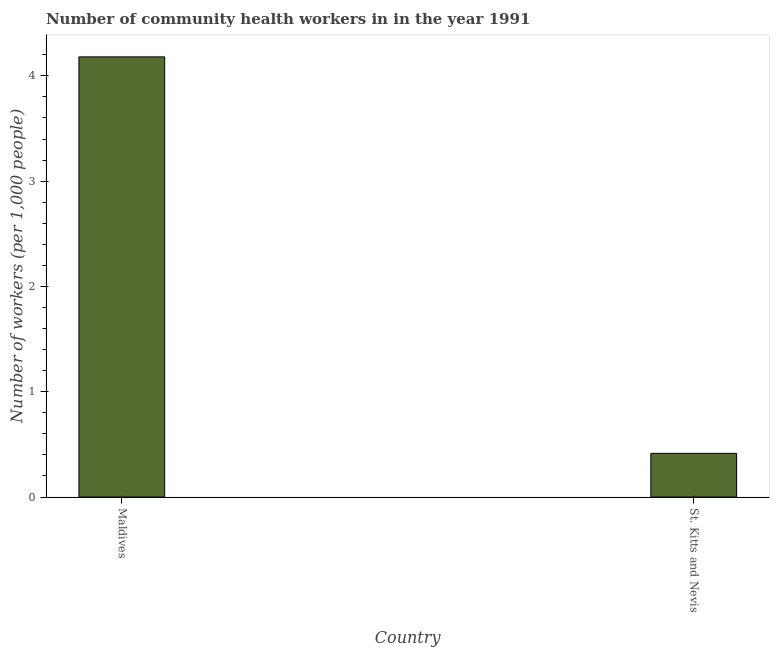Does the graph contain any zero values?
Provide a succinct answer. No. What is the title of the graph?
Keep it short and to the point. Number of community health workers in in the year 1991. What is the label or title of the Y-axis?
Provide a short and direct response. Number of workers (per 1,0 people). What is the number of community health workers in St. Kitts and Nevis?
Make the answer very short. 0.41. Across all countries, what is the maximum number of community health workers?
Your response must be concise. 4.18. Across all countries, what is the minimum number of community health workers?
Your answer should be very brief. 0.41. In which country was the number of community health workers maximum?
Give a very brief answer. Maldives. In which country was the number of community health workers minimum?
Offer a very short reply. St. Kitts and Nevis. What is the sum of the number of community health workers?
Your answer should be compact. 4.59. What is the difference between the number of community health workers in Maldives and St. Kitts and Nevis?
Provide a succinct answer. 3.77. What is the average number of community health workers per country?
Give a very brief answer. 2.3. What is the median number of community health workers?
Make the answer very short. 2.3. What is the ratio of the number of community health workers in Maldives to that in St. Kitts and Nevis?
Ensure brevity in your answer.  10.07. In how many countries, is the number of community health workers greater than the average number of community health workers taken over all countries?
Your response must be concise. 1. How many countries are there in the graph?
Keep it short and to the point. 2. What is the difference between two consecutive major ticks on the Y-axis?
Provide a succinct answer. 1. What is the Number of workers (per 1,000 people) of Maldives?
Keep it short and to the point. 4.18. What is the Number of workers (per 1,000 people) in St. Kitts and Nevis?
Ensure brevity in your answer.  0.41. What is the difference between the Number of workers (per 1,000 people) in Maldives and St. Kitts and Nevis?
Provide a short and direct response. 3.77. What is the ratio of the Number of workers (per 1,000 people) in Maldives to that in St. Kitts and Nevis?
Provide a succinct answer. 10.07. 